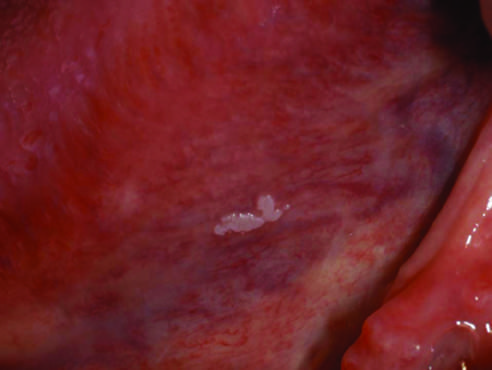s the gross appearance of leukoplakia highly variable?
Answer the question using a single word or phrase. Yes 